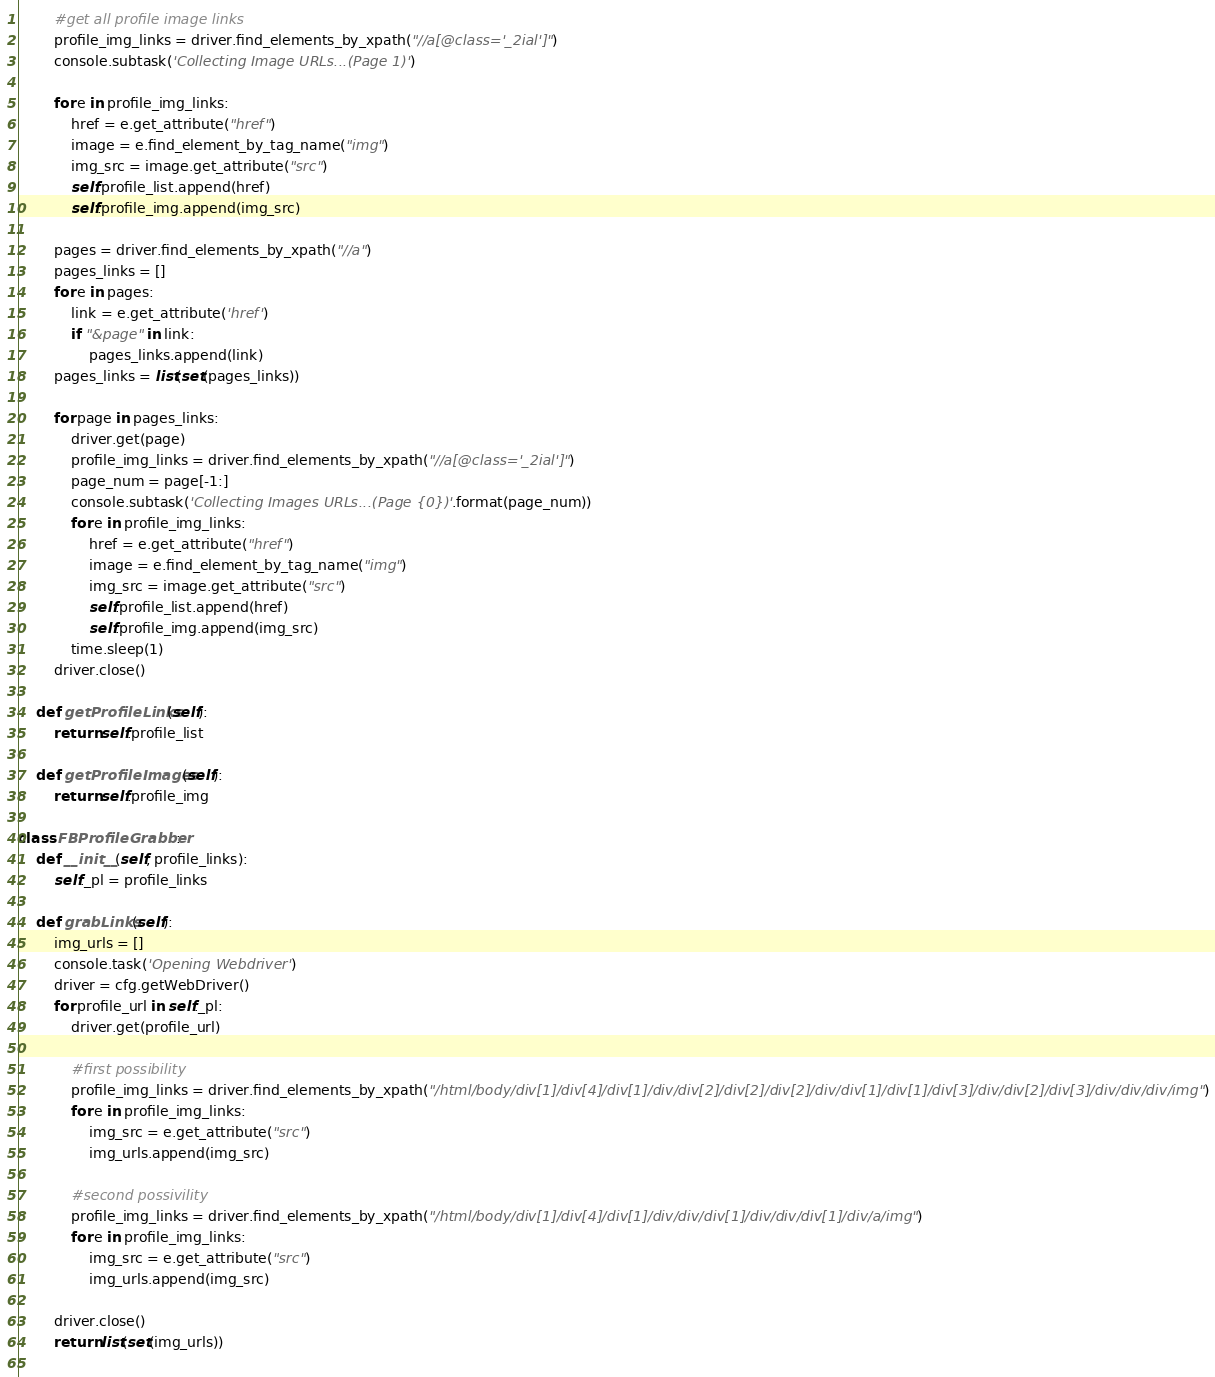Convert code to text. <code><loc_0><loc_0><loc_500><loc_500><_Python_>
        #get all profile image links
        profile_img_links = driver.find_elements_by_xpath("//a[@class='_2ial']")
        console.subtask('Collecting Image URLs...(Page 1)')

        for e in profile_img_links:
            href = e.get_attribute("href")
            image = e.find_element_by_tag_name("img")
            img_src = image.get_attribute("src")
            self.profile_list.append(href)
            self.profile_img.append(img_src)
        
        pages = driver.find_elements_by_xpath("//a")
        pages_links = []
        for e in pages:
            link = e.get_attribute('href')
            if "&page" in link:
                pages_links.append(link)
        pages_links = list(set(pages_links))

        for page in pages_links:
            driver.get(page)
            profile_img_links = driver.find_elements_by_xpath("//a[@class='_2ial']")
            page_num = page[-1:]
            console.subtask('Collecting Images URLs...(Page {0})'.format(page_num))
            for e in profile_img_links:
                href = e.get_attribute("href")
                image = e.find_element_by_tag_name("img")
                img_src = image.get_attribute("src")
                self.profile_list.append(href)
                self.profile_img.append(img_src)
            time.sleep(1)
        driver.close()

    def getProfileLinks(self):
        return self.profile_list

    def getProfileImages(self):
        return self.profile_img

class FBProfileGrabber:
    def __init__(self, profile_links):
        self._pl = profile_links
    
    def grabLinks(self):
        img_urls = []
        console.task('Opening Webdriver')
        driver = cfg.getWebDriver()
        for profile_url in self._pl:
            driver.get(profile_url)

            #first possibility
            profile_img_links = driver.find_elements_by_xpath("/html/body/div[1]/div[4]/div[1]/div/div[2]/div[2]/div[2]/div/div[1]/div[1]/div[3]/div/div[2]/div[3]/div/div/div/img")
            for e in profile_img_links:
                img_src = e.get_attribute("src")
                img_urls.append(img_src)
            
            #second possivility
            profile_img_links = driver.find_elements_by_xpath("/html/body/div[1]/div[4]/div[1]/div/div/div[1]/div/div/div[1]/div/a/img")
            for e in profile_img_links:
                img_src = e.get_attribute("src")
                img_urls.append(img_src)
            
        driver.close()
        return list(set(img_urls))
                </code> 